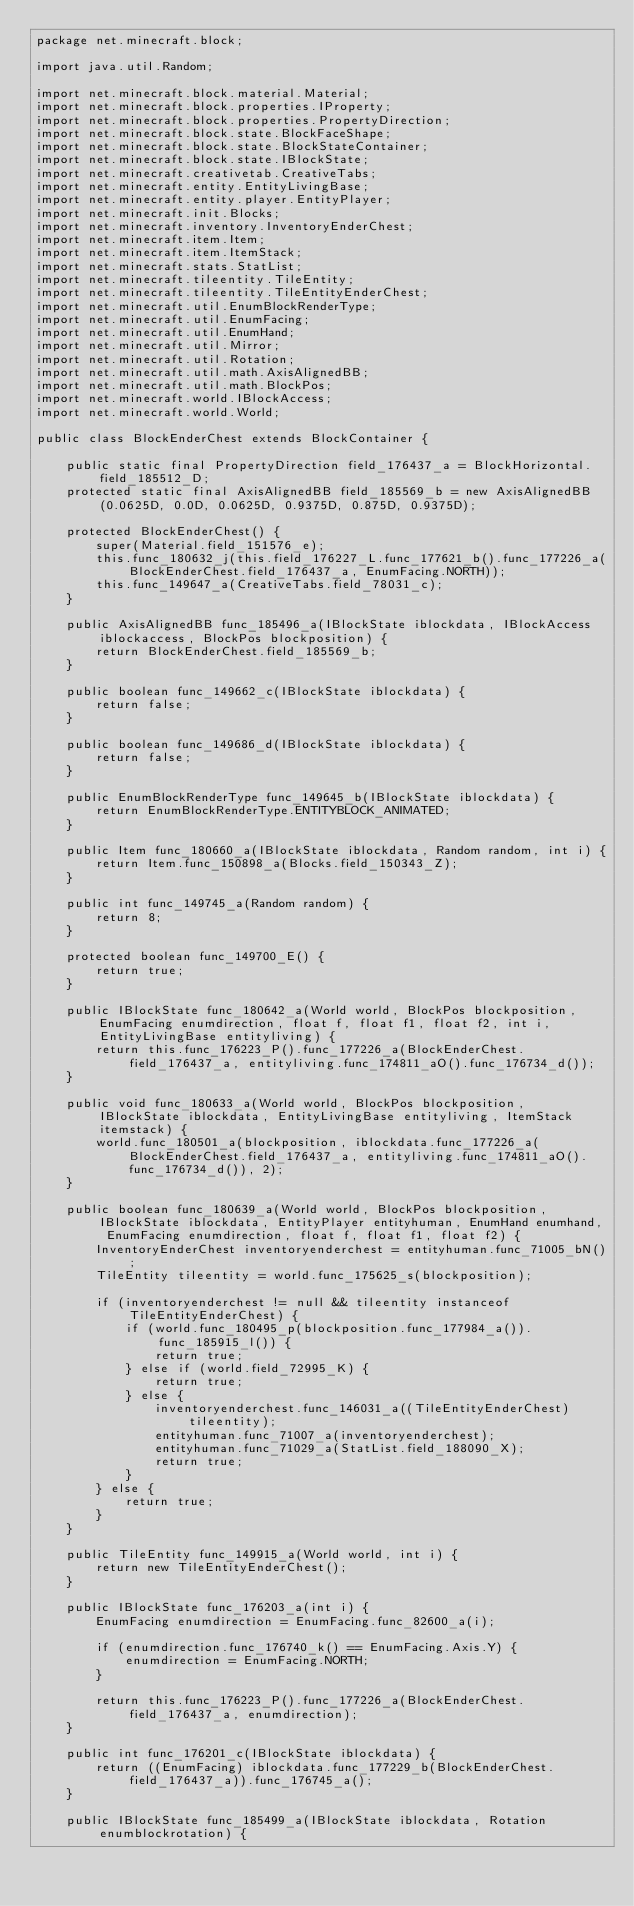Convert code to text. <code><loc_0><loc_0><loc_500><loc_500><_Java_>package net.minecraft.block;

import java.util.Random;

import net.minecraft.block.material.Material;
import net.minecraft.block.properties.IProperty;
import net.minecraft.block.properties.PropertyDirection;
import net.minecraft.block.state.BlockFaceShape;
import net.minecraft.block.state.BlockStateContainer;
import net.minecraft.block.state.IBlockState;
import net.minecraft.creativetab.CreativeTabs;
import net.minecraft.entity.EntityLivingBase;
import net.minecraft.entity.player.EntityPlayer;
import net.minecraft.init.Blocks;
import net.minecraft.inventory.InventoryEnderChest;
import net.minecraft.item.Item;
import net.minecraft.item.ItemStack;
import net.minecraft.stats.StatList;
import net.minecraft.tileentity.TileEntity;
import net.minecraft.tileentity.TileEntityEnderChest;
import net.minecraft.util.EnumBlockRenderType;
import net.minecraft.util.EnumFacing;
import net.minecraft.util.EnumHand;
import net.minecraft.util.Mirror;
import net.minecraft.util.Rotation;
import net.minecraft.util.math.AxisAlignedBB;
import net.minecraft.util.math.BlockPos;
import net.minecraft.world.IBlockAccess;
import net.minecraft.world.World;

public class BlockEnderChest extends BlockContainer {

    public static final PropertyDirection field_176437_a = BlockHorizontal.field_185512_D;
    protected static final AxisAlignedBB field_185569_b = new AxisAlignedBB(0.0625D, 0.0D, 0.0625D, 0.9375D, 0.875D, 0.9375D);

    protected BlockEnderChest() {
        super(Material.field_151576_e);
        this.func_180632_j(this.field_176227_L.func_177621_b().func_177226_a(BlockEnderChest.field_176437_a, EnumFacing.NORTH));
        this.func_149647_a(CreativeTabs.field_78031_c);
    }

    public AxisAlignedBB func_185496_a(IBlockState iblockdata, IBlockAccess iblockaccess, BlockPos blockposition) {
        return BlockEnderChest.field_185569_b;
    }

    public boolean func_149662_c(IBlockState iblockdata) {
        return false;
    }

    public boolean func_149686_d(IBlockState iblockdata) {
        return false;
    }

    public EnumBlockRenderType func_149645_b(IBlockState iblockdata) {
        return EnumBlockRenderType.ENTITYBLOCK_ANIMATED;
    }

    public Item func_180660_a(IBlockState iblockdata, Random random, int i) {
        return Item.func_150898_a(Blocks.field_150343_Z);
    }

    public int func_149745_a(Random random) {
        return 8;
    }

    protected boolean func_149700_E() {
        return true;
    }

    public IBlockState func_180642_a(World world, BlockPos blockposition, EnumFacing enumdirection, float f, float f1, float f2, int i, EntityLivingBase entityliving) {
        return this.func_176223_P().func_177226_a(BlockEnderChest.field_176437_a, entityliving.func_174811_aO().func_176734_d());
    }

    public void func_180633_a(World world, BlockPos blockposition, IBlockState iblockdata, EntityLivingBase entityliving, ItemStack itemstack) {
        world.func_180501_a(blockposition, iblockdata.func_177226_a(BlockEnderChest.field_176437_a, entityliving.func_174811_aO().func_176734_d()), 2);
    }

    public boolean func_180639_a(World world, BlockPos blockposition, IBlockState iblockdata, EntityPlayer entityhuman, EnumHand enumhand, EnumFacing enumdirection, float f, float f1, float f2) {
        InventoryEnderChest inventoryenderchest = entityhuman.func_71005_bN();
        TileEntity tileentity = world.func_175625_s(blockposition);

        if (inventoryenderchest != null && tileentity instanceof TileEntityEnderChest) {
            if (world.func_180495_p(blockposition.func_177984_a()).func_185915_l()) {
                return true;
            } else if (world.field_72995_K) {
                return true;
            } else {
                inventoryenderchest.func_146031_a((TileEntityEnderChest) tileentity);
                entityhuman.func_71007_a(inventoryenderchest);
                entityhuman.func_71029_a(StatList.field_188090_X);
                return true;
            }
        } else {
            return true;
        }
    }

    public TileEntity func_149915_a(World world, int i) {
        return new TileEntityEnderChest();
    }

    public IBlockState func_176203_a(int i) {
        EnumFacing enumdirection = EnumFacing.func_82600_a(i);

        if (enumdirection.func_176740_k() == EnumFacing.Axis.Y) {
            enumdirection = EnumFacing.NORTH;
        }

        return this.func_176223_P().func_177226_a(BlockEnderChest.field_176437_a, enumdirection);
    }

    public int func_176201_c(IBlockState iblockdata) {
        return ((EnumFacing) iblockdata.func_177229_b(BlockEnderChest.field_176437_a)).func_176745_a();
    }

    public IBlockState func_185499_a(IBlockState iblockdata, Rotation enumblockrotation) {</code> 